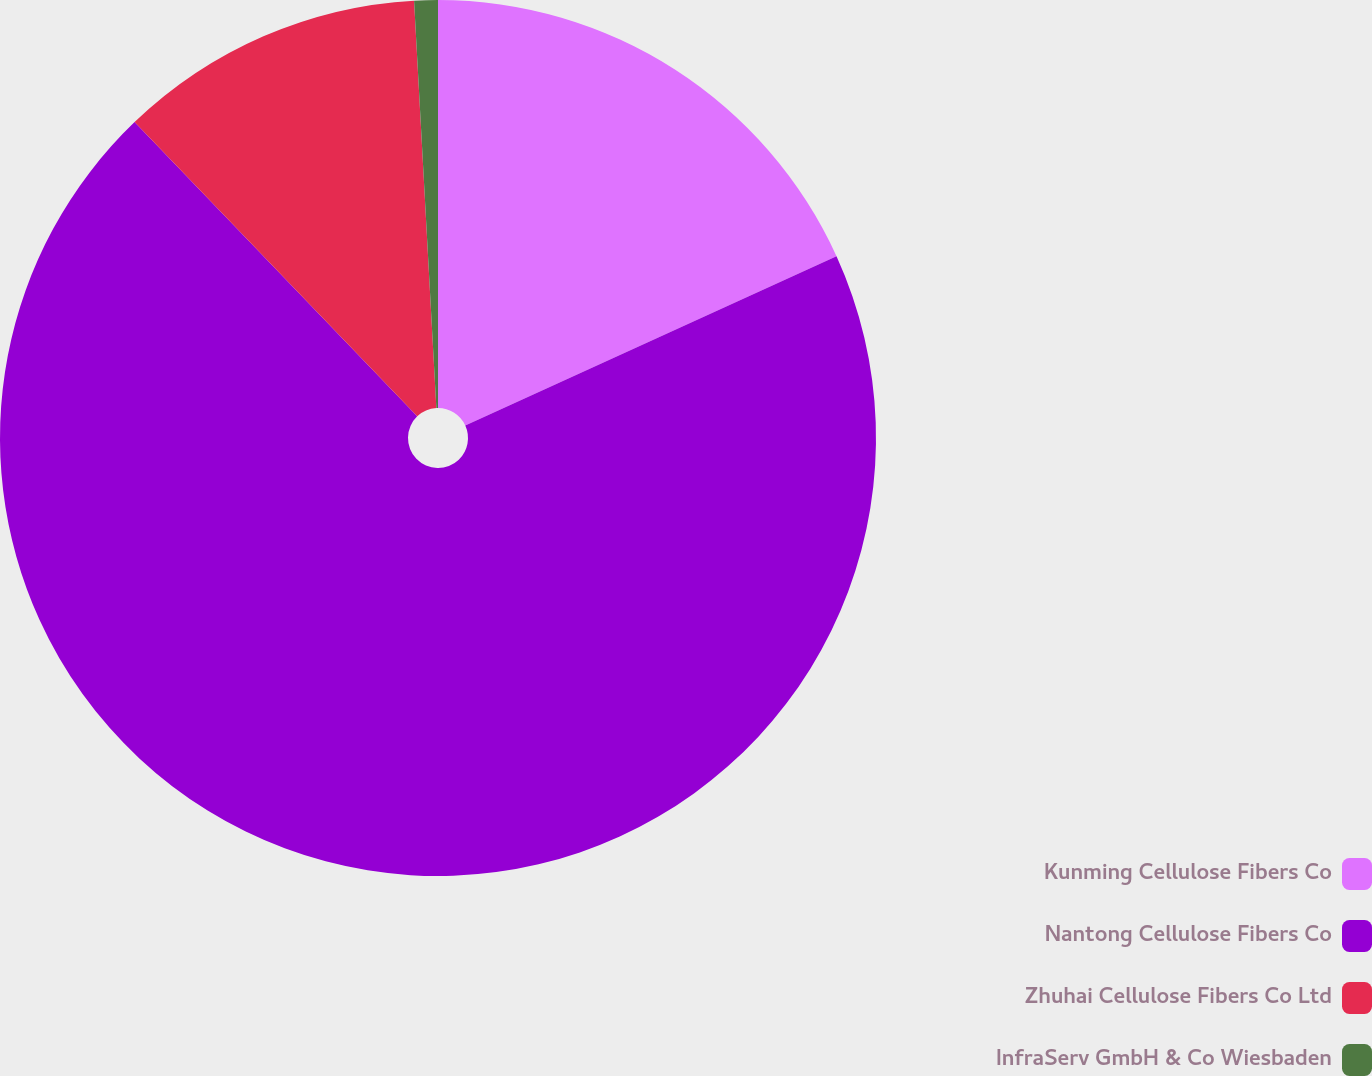Convert chart. <chart><loc_0><loc_0><loc_500><loc_500><pie_chart><fcel>Kunming Cellulose Fibers Co<fcel>Nantong Cellulose Fibers Co<fcel>Zhuhai Cellulose Fibers Co Ltd<fcel>InfraServ GmbH & Co Wiesbaden<nl><fcel>18.19%<fcel>69.63%<fcel>11.31%<fcel>0.87%<nl></chart> 